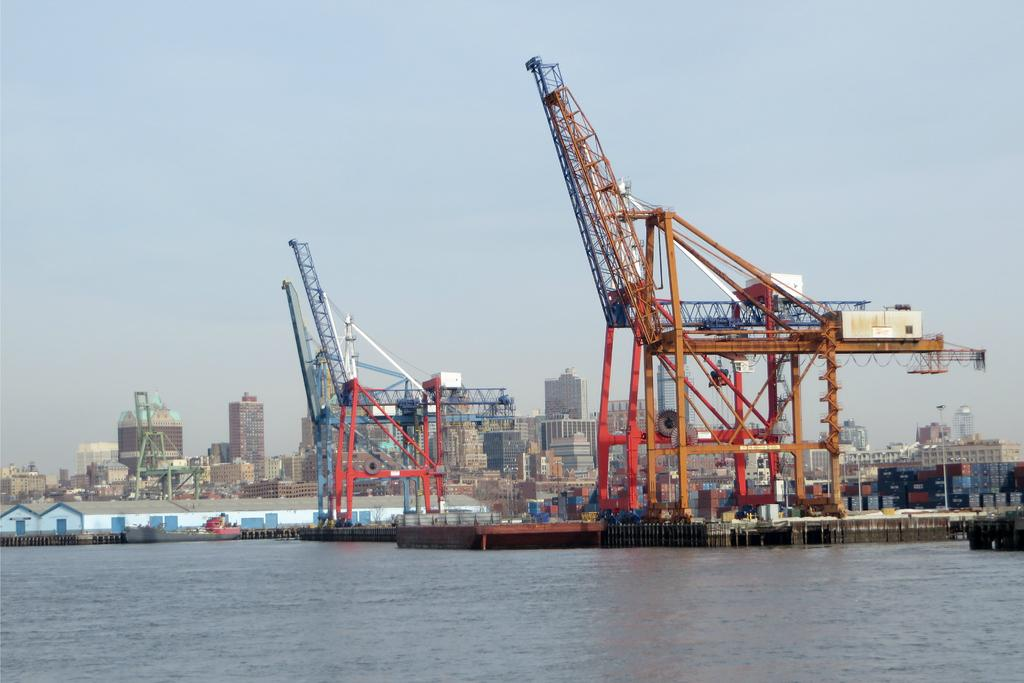What is the main subject in the foreground of the image? There is a port in the foreground of the image. What can be seen in the background of the image? There are buildings visible in the background of the image, and the sky is also visible. Where are the flowers growing in the image? There are no flowers present in the image. What rule is being enforced in the image? There is no indication of any rules being enforced in the image. 